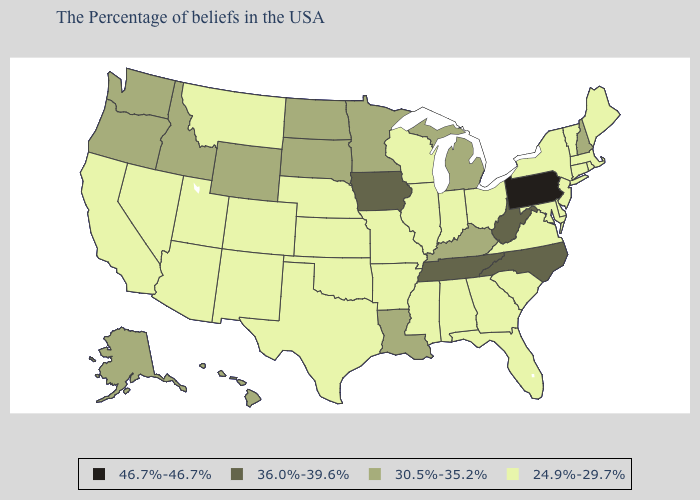Among the states that border Wyoming , which have the highest value?
Write a very short answer. South Dakota, Idaho. What is the lowest value in the West?
Concise answer only. 24.9%-29.7%. What is the highest value in the USA?
Concise answer only. 46.7%-46.7%. Among the states that border Wisconsin , which have the highest value?
Be succinct. Iowa. What is the highest value in the Northeast ?
Concise answer only. 46.7%-46.7%. Does Kentucky have the highest value in the South?
Keep it brief. No. Does Virginia have the lowest value in the USA?
Concise answer only. Yes. What is the lowest value in the USA?
Answer briefly. 24.9%-29.7%. Name the states that have a value in the range 24.9%-29.7%?
Concise answer only. Maine, Massachusetts, Rhode Island, Vermont, Connecticut, New York, New Jersey, Delaware, Maryland, Virginia, South Carolina, Ohio, Florida, Georgia, Indiana, Alabama, Wisconsin, Illinois, Mississippi, Missouri, Arkansas, Kansas, Nebraska, Oklahoma, Texas, Colorado, New Mexico, Utah, Montana, Arizona, Nevada, California. Which states have the highest value in the USA?
Answer briefly. Pennsylvania. Among the states that border Washington , which have the highest value?
Be succinct. Idaho, Oregon. Among the states that border Delaware , does Pennsylvania have the lowest value?
Give a very brief answer. No. What is the lowest value in states that border Pennsylvania?
Answer briefly. 24.9%-29.7%. Does the map have missing data?
Keep it brief. No. Is the legend a continuous bar?
Concise answer only. No. 